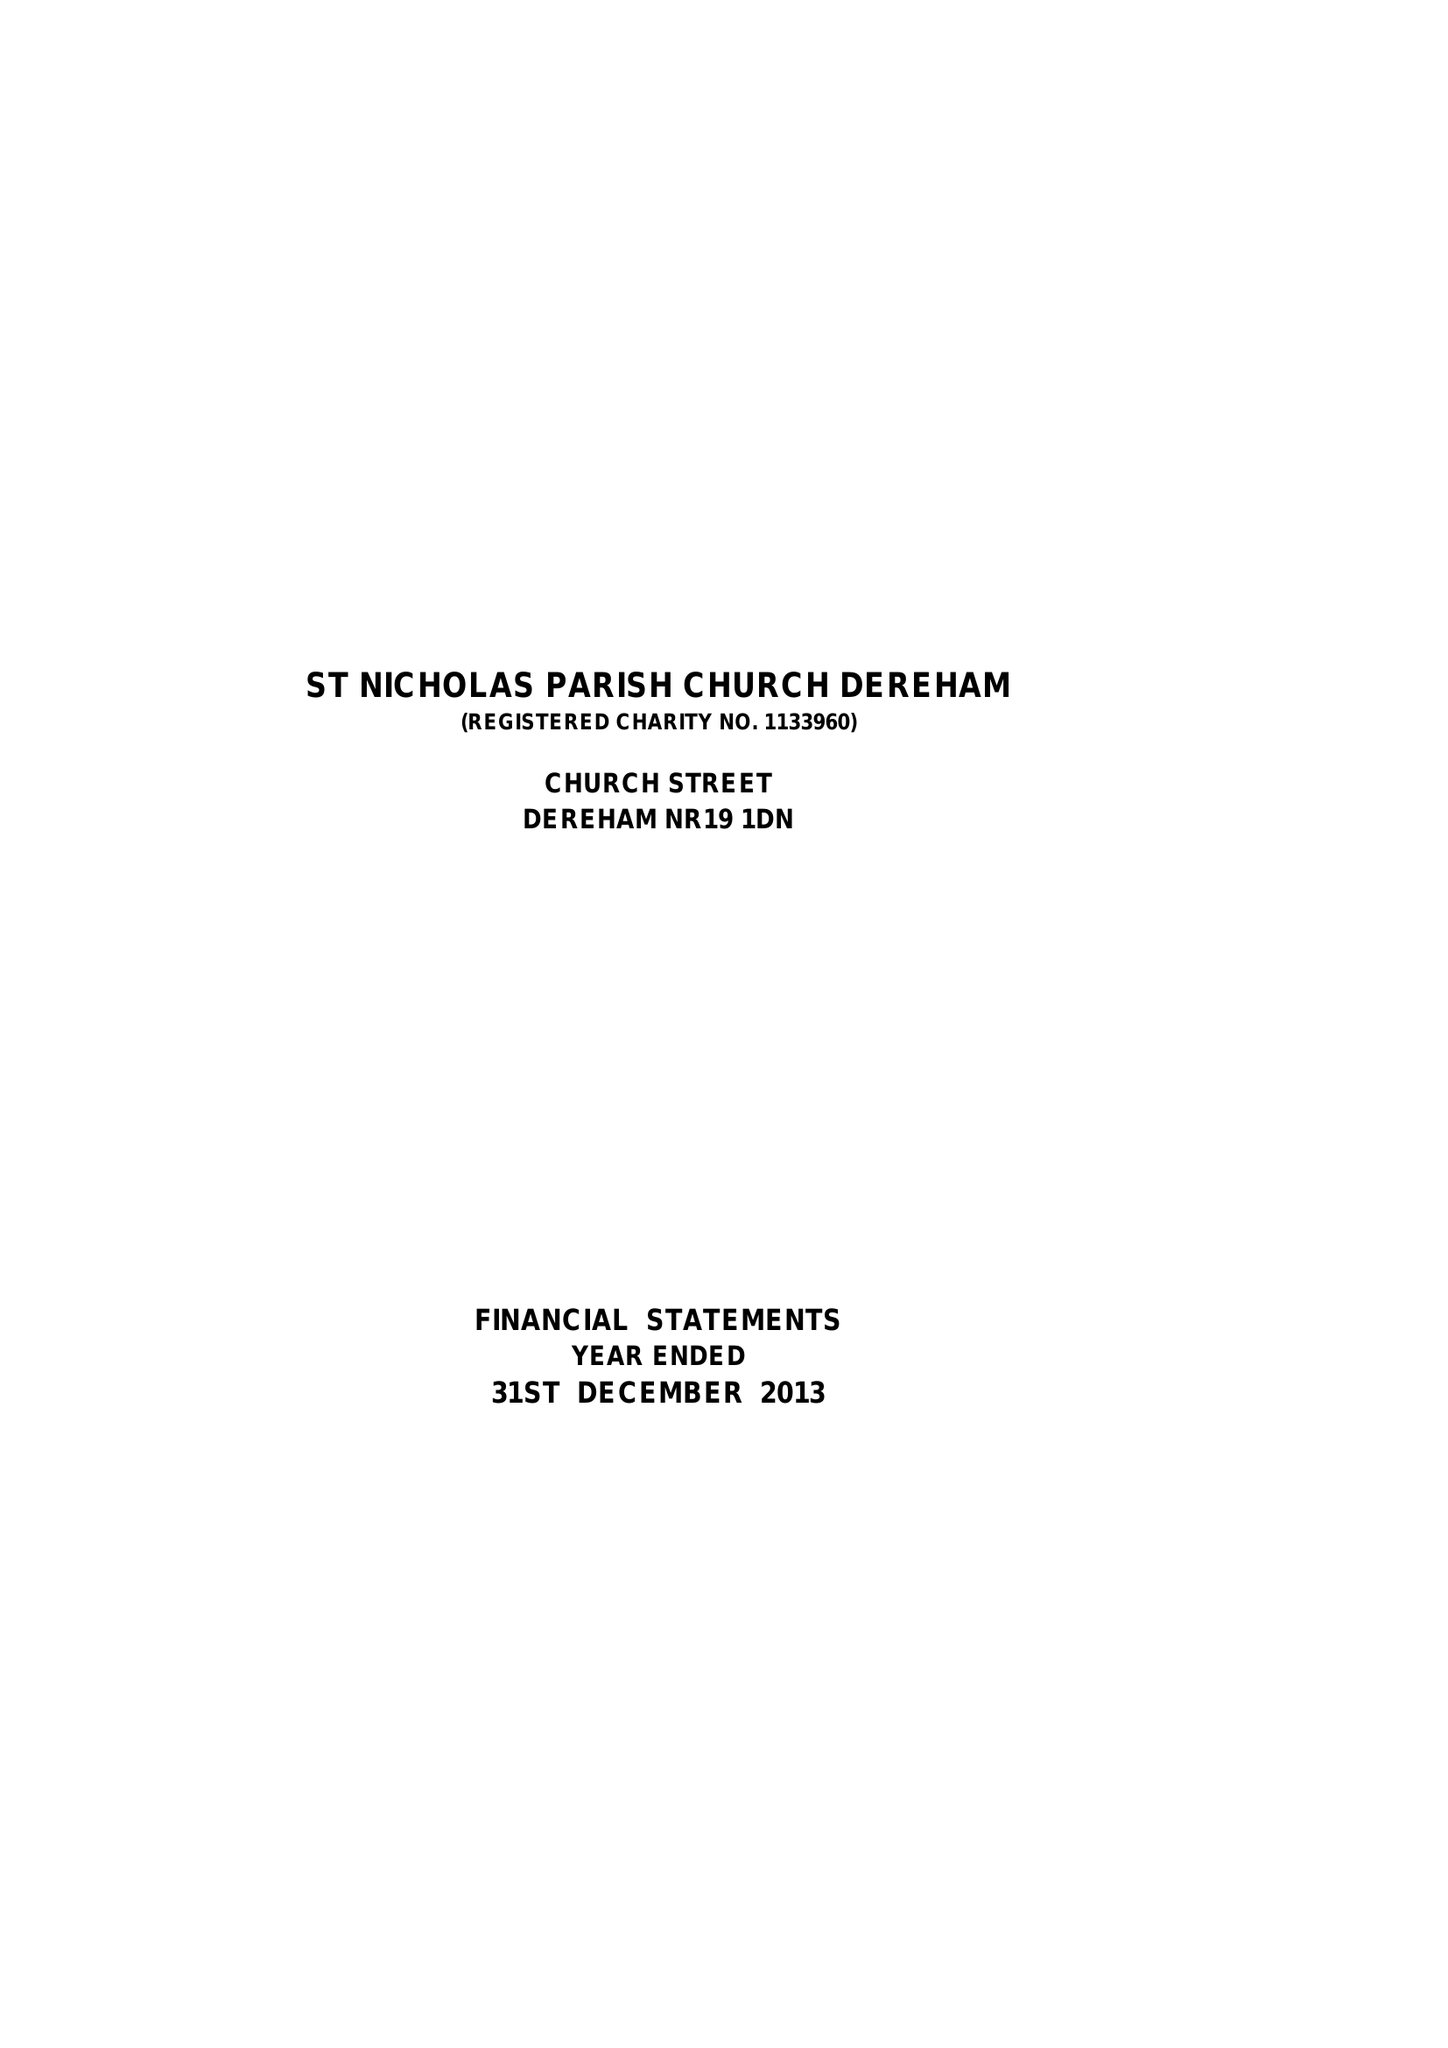What is the value for the report_date?
Answer the question using a single word or phrase. 2013-12-31 